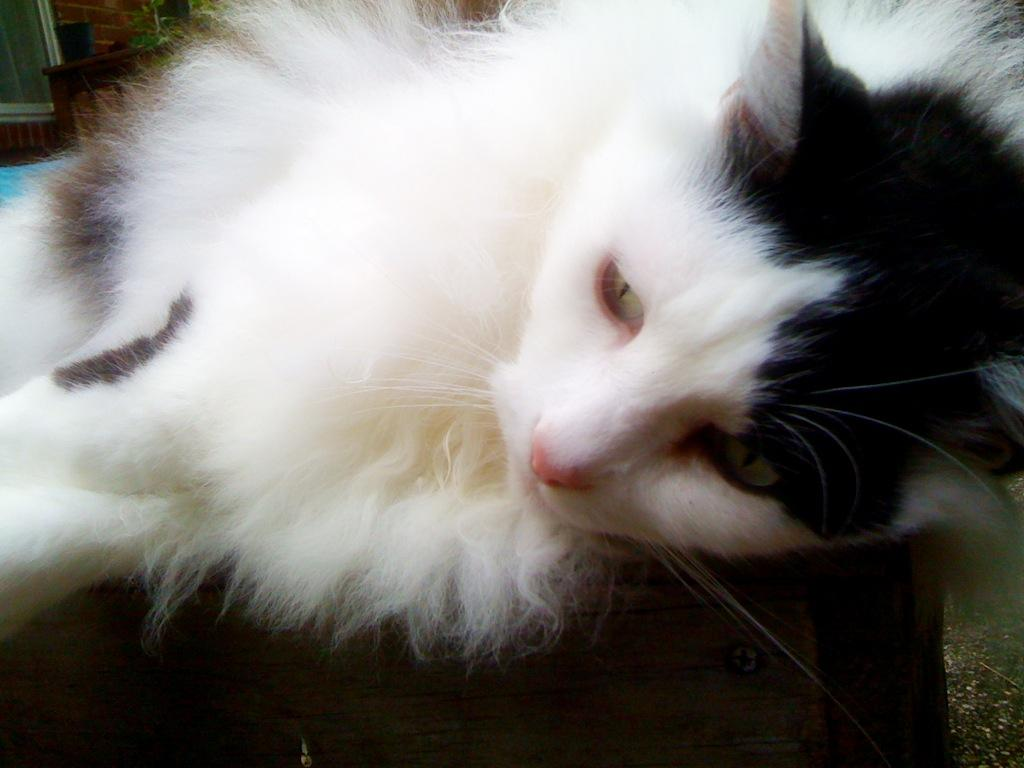What animal is present in the image? There is a cat in the image. Where is the cat located? The cat is lying on a table. What can be seen in the background of the image? There are chairs and a wall in the background of the image. What type of room might the image have been taken in? The image may have been taken in a hall. What type of toys can be seen in the image? There are no toys present in the image; it features a cat lying on a table with chairs and a wall in the background. 